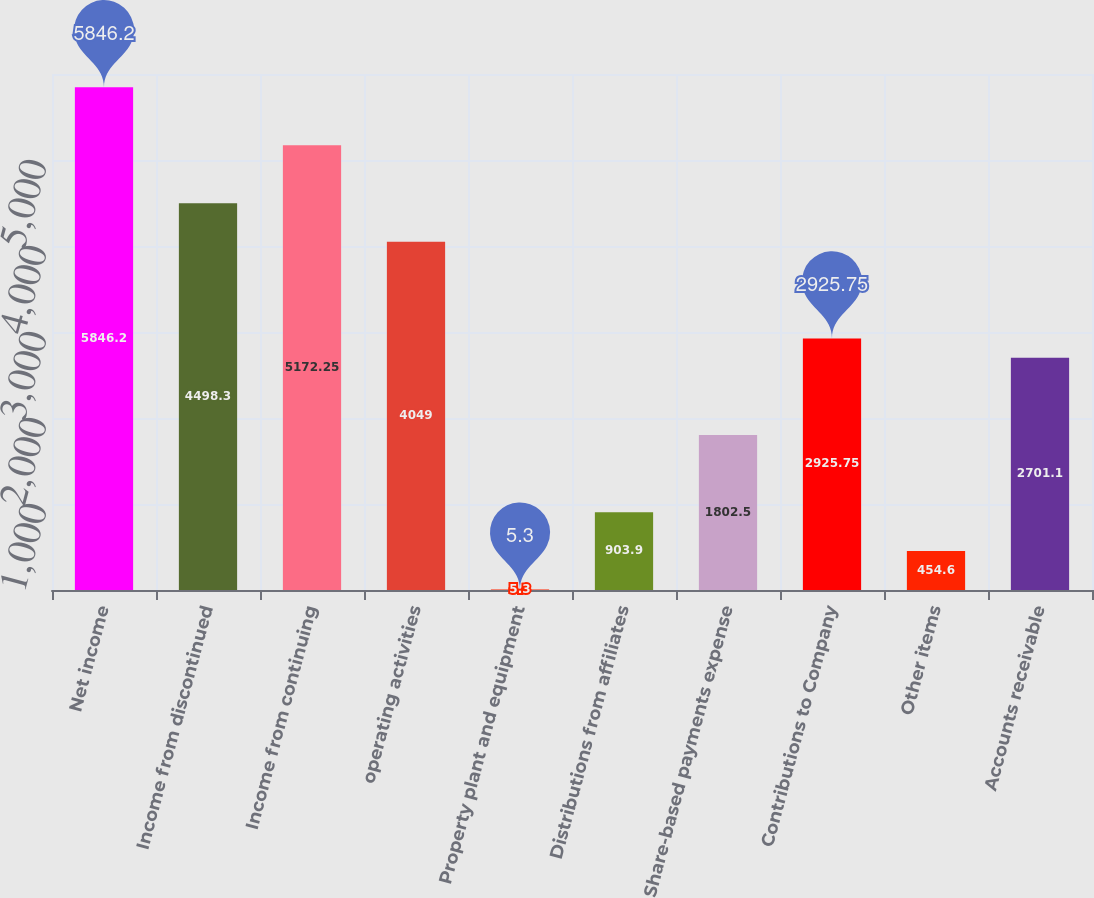Convert chart to OTSL. <chart><loc_0><loc_0><loc_500><loc_500><bar_chart><fcel>Net income<fcel>Income from discontinued<fcel>Income from continuing<fcel>operating activities<fcel>Property plant and equipment<fcel>Distributions from affiliates<fcel>Share-based payments expense<fcel>Contributions to Company<fcel>Other items<fcel>Accounts receivable<nl><fcel>5846.2<fcel>4498.3<fcel>5172.25<fcel>4049<fcel>5.3<fcel>903.9<fcel>1802.5<fcel>2925.75<fcel>454.6<fcel>2701.1<nl></chart> 